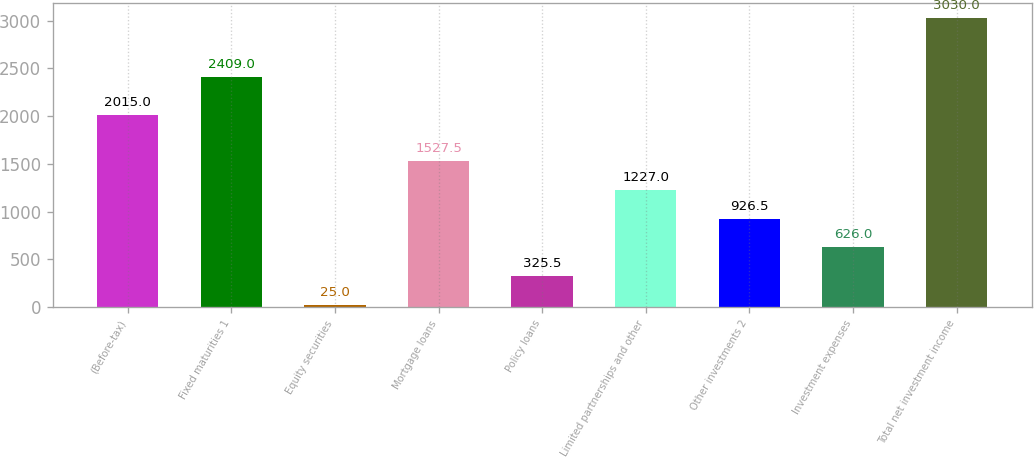Convert chart. <chart><loc_0><loc_0><loc_500><loc_500><bar_chart><fcel>(Before-tax)<fcel>Fixed maturities 1<fcel>Equity securities<fcel>Mortgage loans<fcel>Policy loans<fcel>Limited partnerships and other<fcel>Other investments 2<fcel>Investment expenses<fcel>Total net investment income<nl><fcel>2015<fcel>2409<fcel>25<fcel>1527.5<fcel>325.5<fcel>1227<fcel>926.5<fcel>626<fcel>3030<nl></chart> 